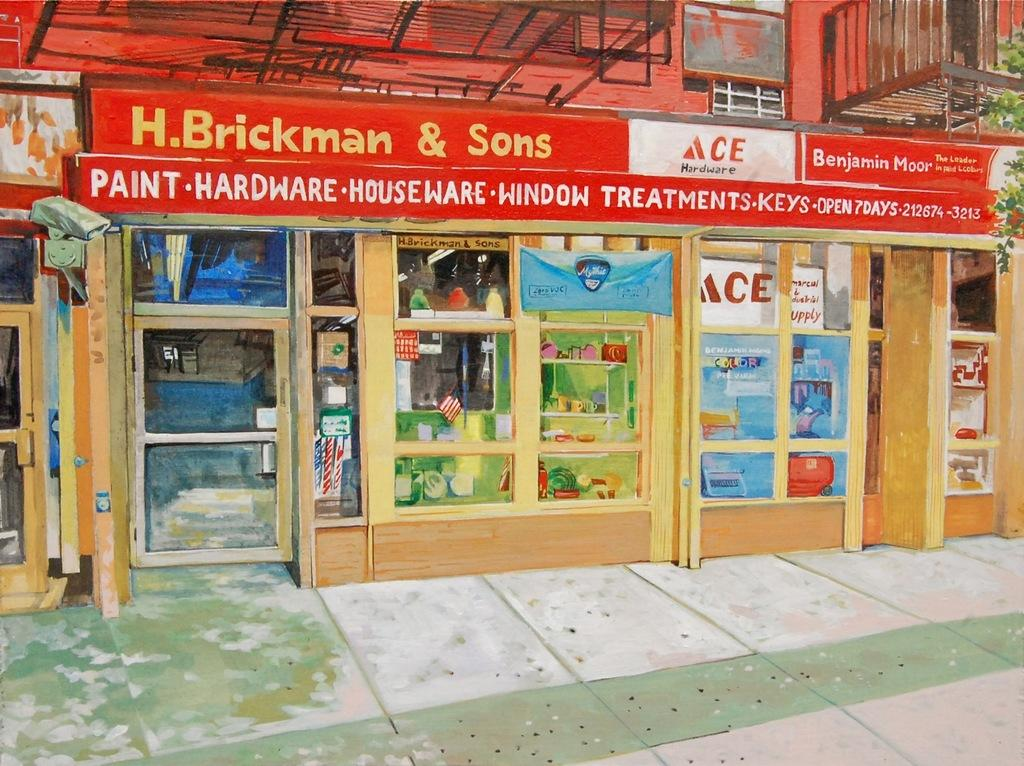Provide a one-sentence caption for the provided image. the store front gor h.brckman and sons hardware. 